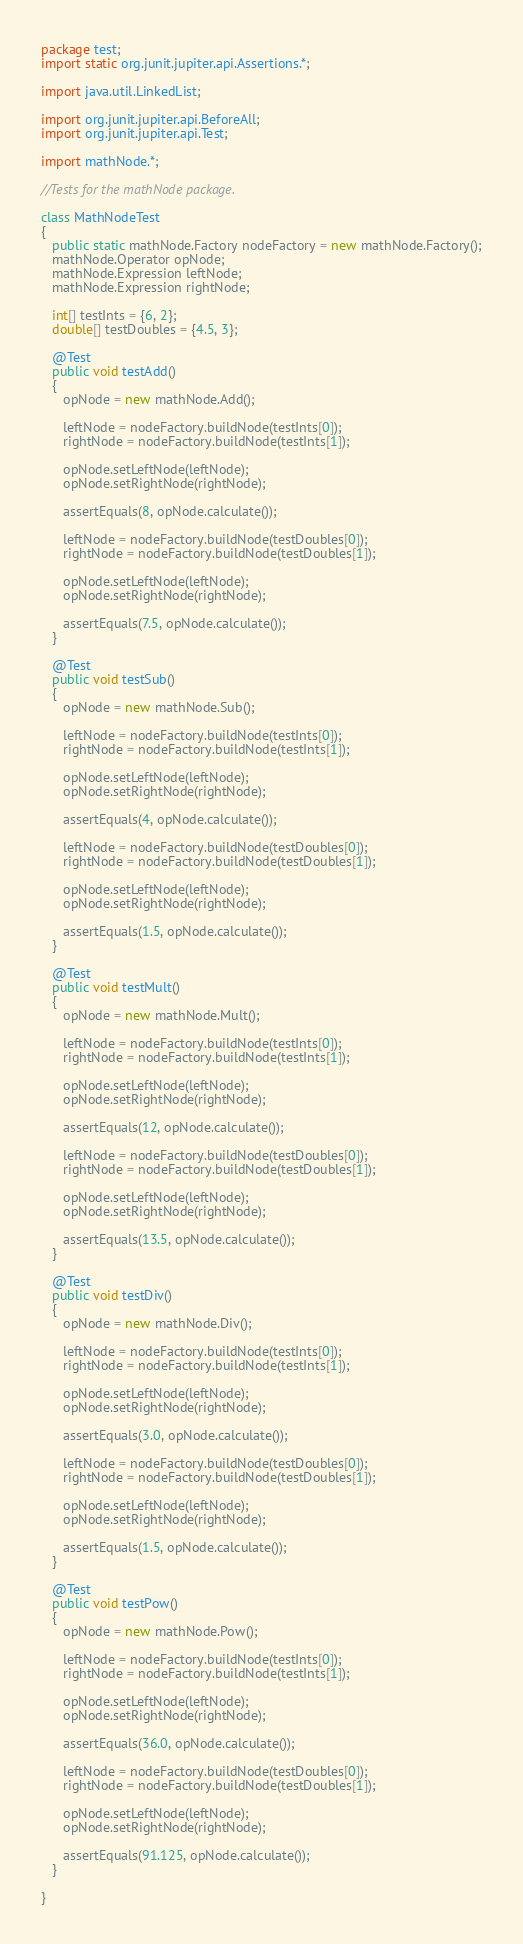Convert code to text. <code><loc_0><loc_0><loc_500><loc_500><_Java_>package test;
import static org.junit.jupiter.api.Assertions.*;

import java.util.LinkedList;

import org.junit.jupiter.api.BeforeAll;
import org.junit.jupiter.api.Test;

import mathNode.*;

//Tests for the mathNode package.

class MathNodeTest
{
   public static mathNode.Factory nodeFactory = new mathNode.Factory();
   mathNode.Operator opNode;
   mathNode.Expression leftNode;
   mathNode.Expression rightNode;
   
   int[] testInts = {6, 2};
   double[] testDoubles = {4.5, 3};

   @Test
   public void testAdd()
   {
      opNode = new mathNode.Add();
      
      leftNode = nodeFactory.buildNode(testInts[0]);
      rightNode = nodeFactory.buildNode(testInts[1]);
      
      opNode.setLeftNode(leftNode);
      opNode.setRightNode(rightNode);
      
      assertEquals(8, opNode.calculate());
      
      leftNode = nodeFactory.buildNode(testDoubles[0]);
      rightNode = nodeFactory.buildNode(testDoubles[1]);
      
      opNode.setLeftNode(leftNode);
      opNode.setRightNode(rightNode);
      
      assertEquals(7.5, opNode.calculate());
   }
   
   @Test
   public void testSub()
   {
      opNode = new mathNode.Sub();
      
      leftNode = nodeFactory.buildNode(testInts[0]);
      rightNode = nodeFactory.buildNode(testInts[1]);
      
      opNode.setLeftNode(leftNode);
      opNode.setRightNode(rightNode);
      
      assertEquals(4, opNode.calculate());
      
      leftNode = nodeFactory.buildNode(testDoubles[0]);
      rightNode = nodeFactory.buildNode(testDoubles[1]);
      
      opNode.setLeftNode(leftNode);
      opNode.setRightNode(rightNode);
      
      assertEquals(1.5, opNode.calculate());
   }
   
   @Test
   public void testMult()
   {
      opNode = new mathNode.Mult();
      
      leftNode = nodeFactory.buildNode(testInts[0]);
      rightNode = nodeFactory.buildNode(testInts[1]);
      
      opNode.setLeftNode(leftNode);
      opNode.setRightNode(rightNode);
      
      assertEquals(12, opNode.calculate());
      
      leftNode = nodeFactory.buildNode(testDoubles[0]);
      rightNode = nodeFactory.buildNode(testDoubles[1]);
      
      opNode.setLeftNode(leftNode);
      opNode.setRightNode(rightNode);
      
      assertEquals(13.5, opNode.calculate());
   }
   
   @Test
   public void testDiv()
   {
      opNode = new mathNode.Div();
      
      leftNode = nodeFactory.buildNode(testInts[0]);
      rightNode = nodeFactory.buildNode(testInts[1]);
      
      opNode.setLeftNode(leftNode);
      opNode.setRightNode(rightNode);
      
      assertEquals(3.0, opNode.calculate());
      
      leftNode = nodeFactory.buildNode(testDoubles[0]);
      rightNode = nodeFactory.buildNode(testDoubles[1]);
      
      opNode.setLeftNode(leftNode);
      opNode.setRightNode(rightNode);
      
      assertEquals(1.5, opNode.calculate());
   }
   
   @Test
   public void testPow()
   {
      opNode = new mathNode.Pow();
      
      leftNode = nodeFactory.buildNode(testInts[0]);
      rightNode = nodeFactory.buildNode(testInts[1]);
      
      opNode.setLeftNode(leftNode);
      opNode.setRightNode(rightNode);
      
      assertEquals(36.0, opNode.calculate());
      
      leftNode = nodeFactory.buildNode(testDoubles[0]);
      rightNode = nodeFactory.buildNode(testDoubles[1]);
      
      opNode.setLeftNode(leftNode);
      opNode.setRightNode(rightNode);
      
      assertEquals(91.125, opNode.calculate());
   }

}</code> 